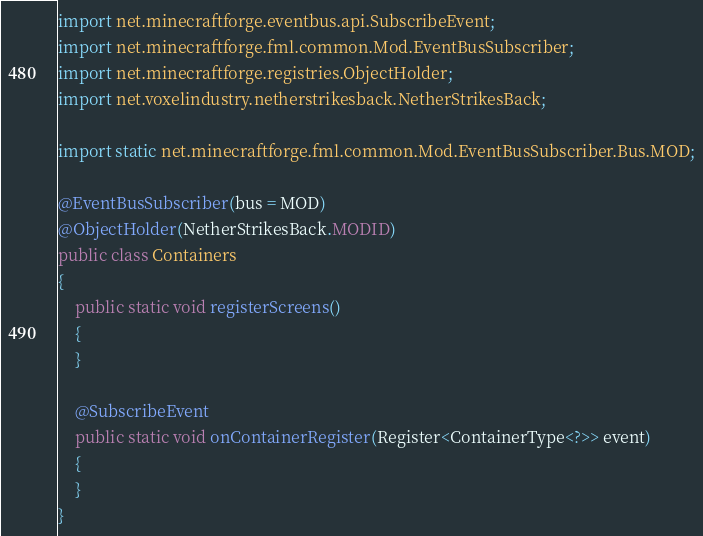<code> <loc_0><loc_0><loc_500><loc_500><_Java_>import net.minecraftforge.eventbus.api.SubscribeEvent;
import net.minecraftforge.fml.common.Mod.EventBusSubscriber;
import net.minecraftforge.registries.ObjectHolder;
import net.voxelindustry.netherstrikesback.NetherStrikesBack;

import static net.minecraftforge.fml.common.Mod.EventBusSubscriber.Bus.MOD;

@EventBusSubscriber(bus = MOD)
@ObjectHolder(NetherStrikesBack.MODID)
public class Containers
{
    public static void registerScreens()
    {
    }

    @SubscribeEvent
    public static void onContainerRegister(Register<ContainerType<?>> event)
    {
    }
}
</code> 